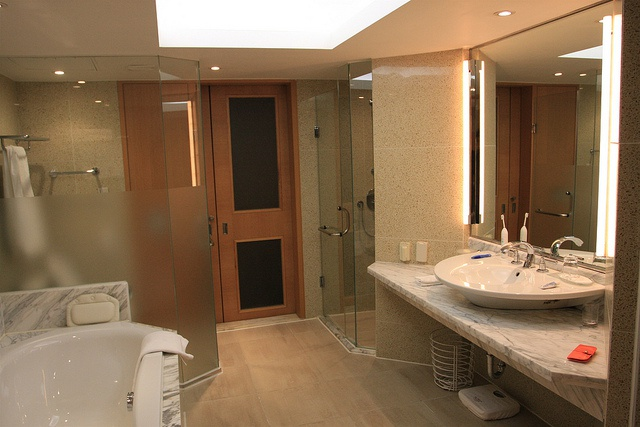Describe the objects in this image and their specific colors. I can see sink in brown, tan, and gray tones, handbag in brown, salmon, red, and tan tones, cup in brown, maroon, and gray tones, toothbrush in brown and tan tones, and toothbrush in brown and tan tones in this image. 